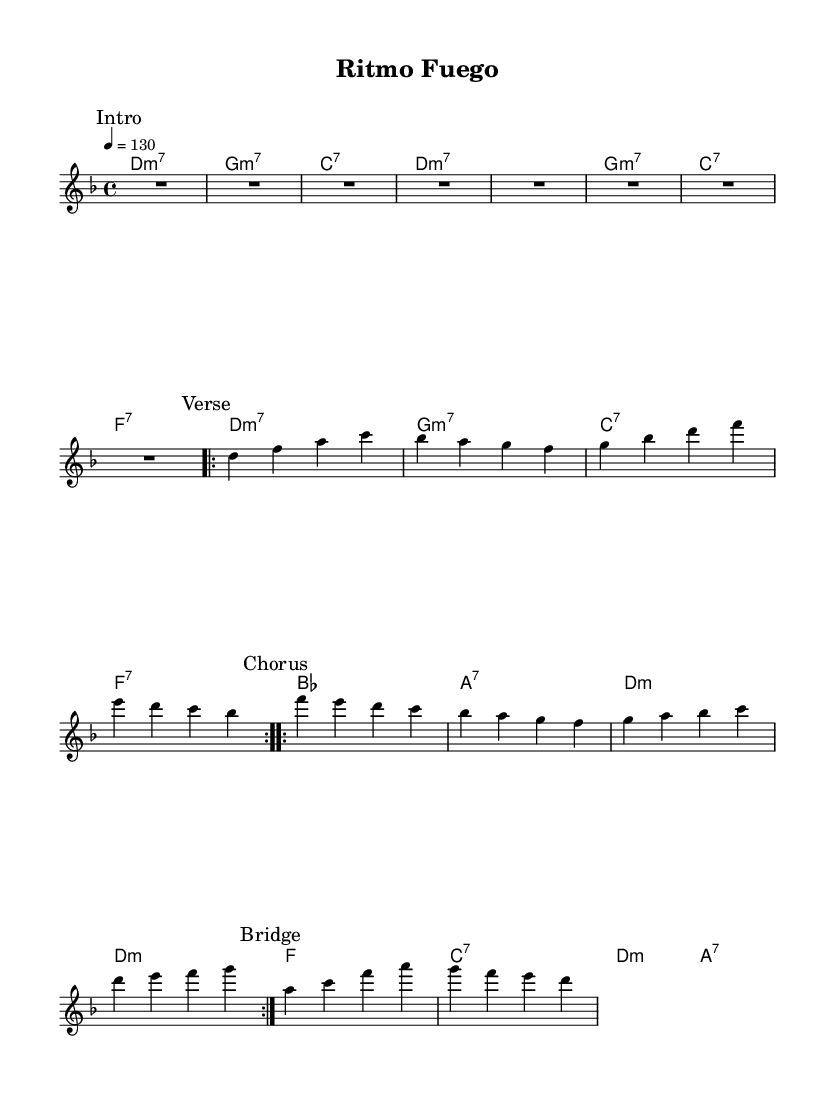What is the key signature of this music? The key signature in the music is D minor, indicated by one flat (B flat) and the presence of D in the key signature section.
Answer: D minor What is the time signature of the piece? The time signature is 4/4, which is shown at the beginning of the score and indicates four beats per measure.
Answer: 4/4 What is the tempo marking for this piece? The tempo marking indicates 130 beats per minute, as noted at the start with "4 = 130." This means each quarter note is to be played at this speed.
Answer: 130 How many measures are in the chorus section? The chorus section consists of 8 measures, as indicated by the repeated volta and counting through the measures shown under the "Chorus" marking.
Answer: 8 What type of chords are used in the harmonies section? The harmonies consist of major and minor seventh chords, as indicated by the chord symbols such as m7, 7, and the corresponding note formations in the chord mode section.
Answer: Major and minor seventh chords What is the structure of the overall piece? The piece has a structure of Intro, Verse, Chorus, and Bridge, as clearly marked within the music. The repeated sections suggest a familiar format typical in dance music for easier memorization.
Answer: Intro, Verse, Chorus, Bridge 